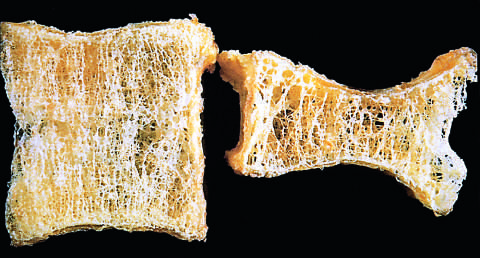what is the osteoporotic vertebral body shorten by?
Answer the question using a single word or phrase. Compression fractures 